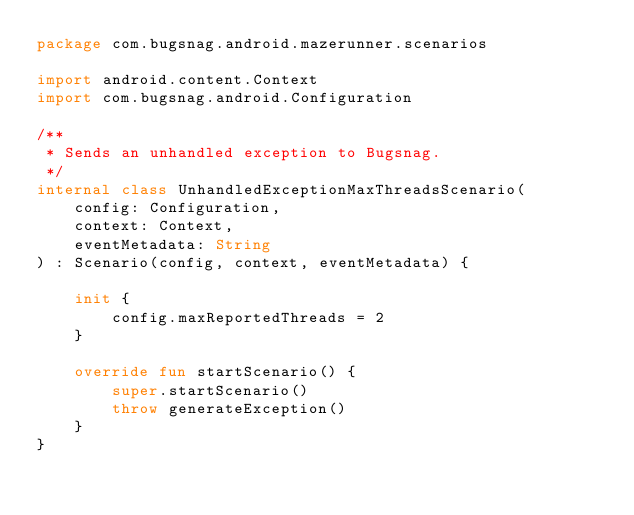Convert code to text. <code><loc_0><loc_0><loc_500><loc_500><_Kotlin_>package com.bugsnag.android.mazerunner.scenarios

import android.content.Context
import com.bugsnag.android.Configuration

/**
 * Sends an unhandled exception to Bugsnag.
 */
internal class UnhandledExceptionMaxThreadsScenario(
    config: Configuration,
    context: Context,
    eventMetadata: String
) : Scenario(config, context, eventMetadata) {

    init {
        config.maxReportedThreads = 2
    }

    override fun startScenario() {
        super.startScenario()
        throw generateException()
    }
}
</code> 